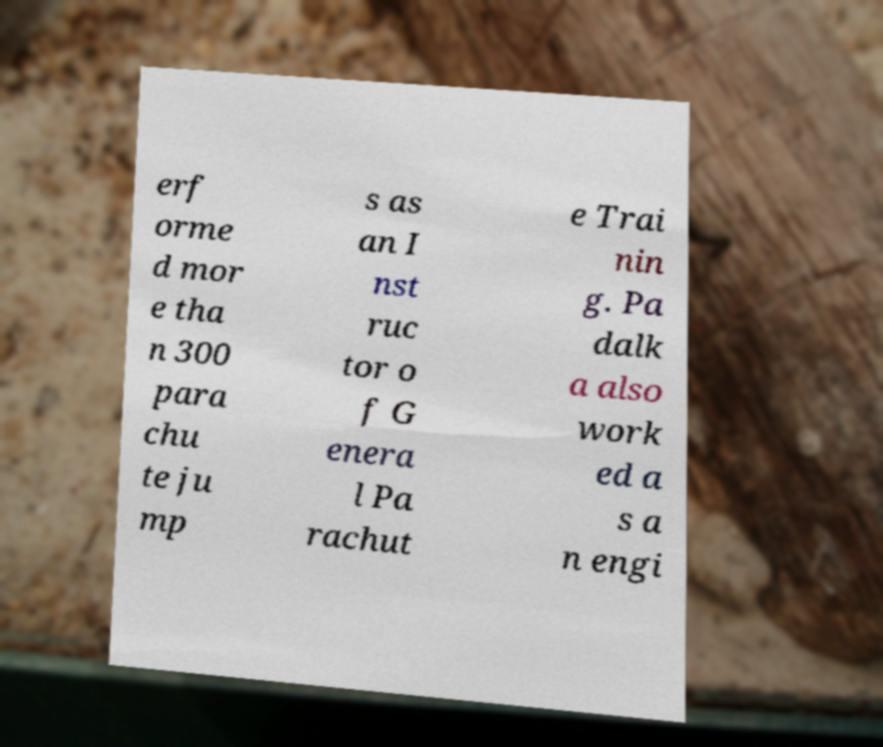Could you extract and type out the text from this image? erf orme d mor e tha n 300 para chu te ju mp s as an I nst ruc tor o f G enera l Pa rachut e Trai nin g. Pa dalk a also work ed a s a n engi 